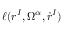Convert formula to latex. <formula><loc_0><loc_0><loc_500><loc_500>\ell ( r ^ { I } , \Omega ^ { \alpha } , \dot { r } ^ { I } )</formula> 